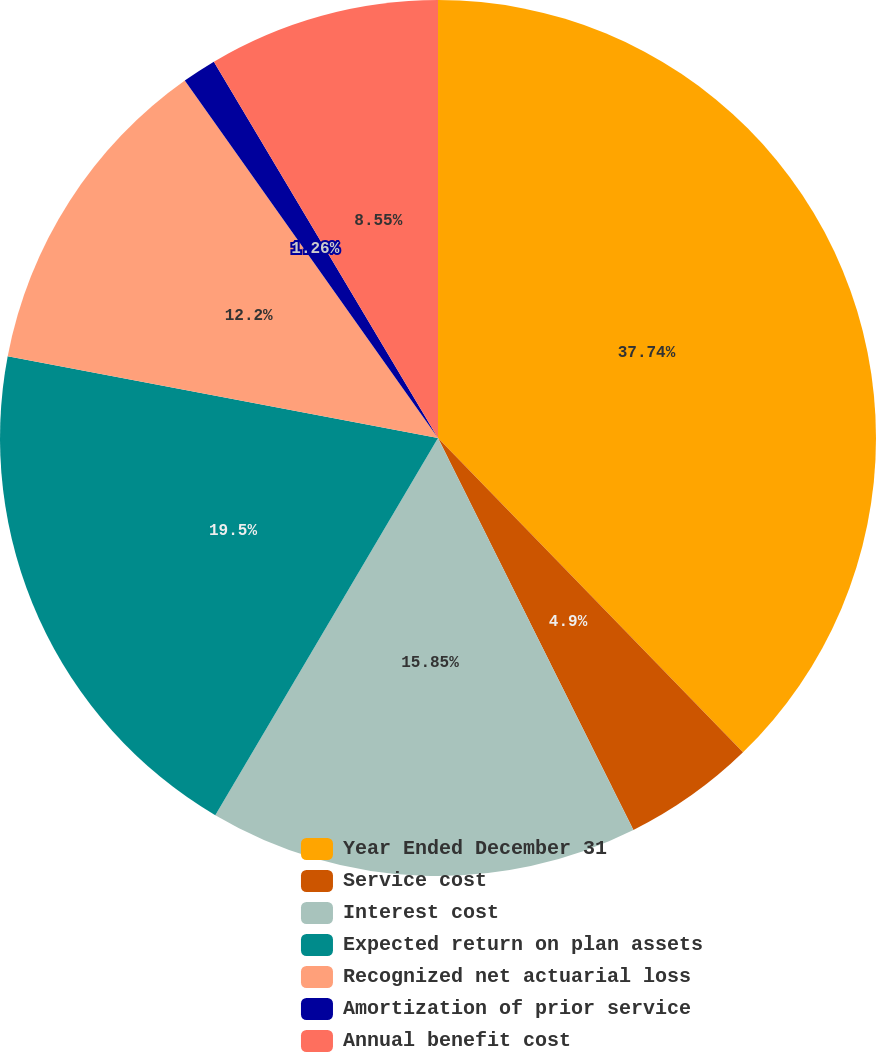<chart> <loc_0><loc_0><loc_500><loc_500><pie_chart><fcel>Year Ended December 31<fcel>Service cost<fcel>Interest cost<fcel>Expected return on plan assets<fcel>Recognized net actuarial loss<fcel>Amortization of prior service<fcel>Annual benefit cost<nl><fcel>37.74%<fcel>4.9%<fcel>15.85%<fcel>19.5%<fcel>12.2%<fcel>1.26%<fcel>8.55%<nl></chart> 